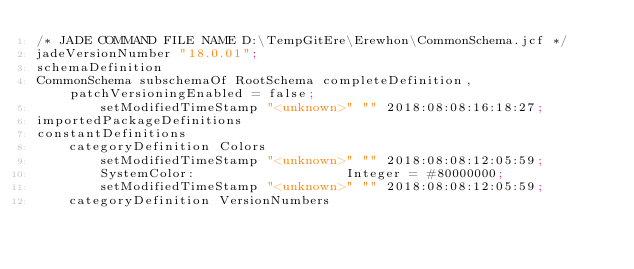<code> <loc_0><loc_0><loc_500><loc_500><_Scheme_>/* JADE COMMAND FILE NAME D:\TempGitEre\Erewhon\CommonSchema.jcf */
jadeVersionNumber "18.0.01";
schemaDefinition
CommonSchema subschemaOf RootSchema completeDefinition, patchVersioningEnabled = false;
		setModifiedTimeStamp "<unknown>" "" 2018:08:08:16:18:27;
importedPackageDefinitions
constantDefinitions
	categoryDefinition Colors
		setModifiedTimeStamp "<unknown>" "" 2018:08:08:12:05:59;
		SystemColor:                   Integer = #80000000;
		setModifiedTimeStamp "<unknown>" "" 2018:08:08:12:05:59;
	categoryDefinition VersionNumbers</code> 